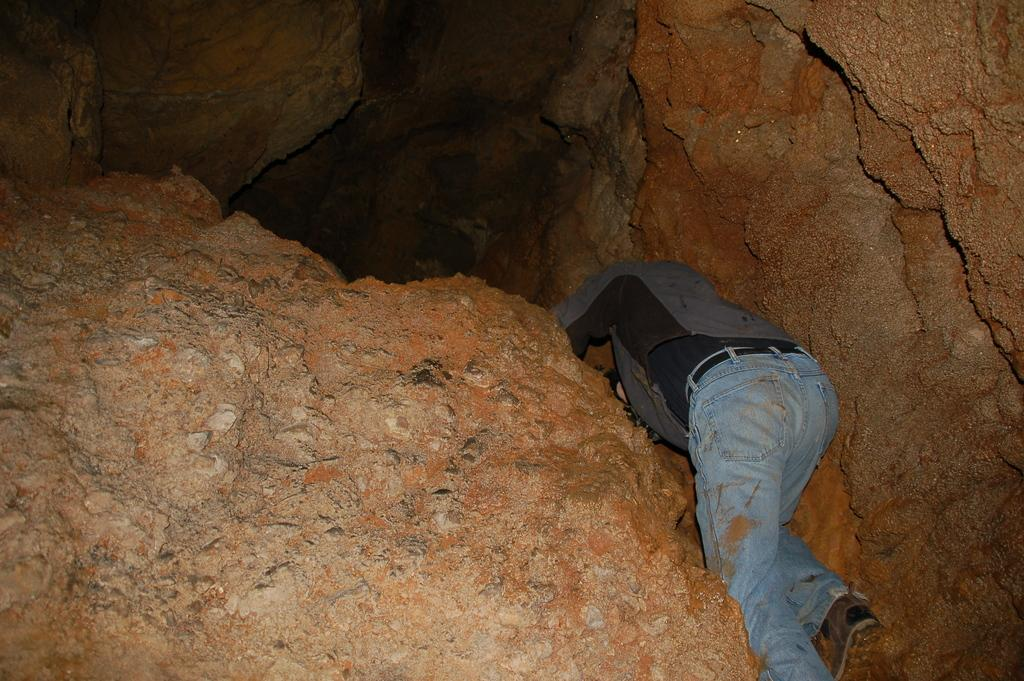What is present in the image? There is a man and rocks in the image. Can you describe the man in the image? The provided facts do not give any specific details about the man, so we cannot describe him further. What type of cushion is being used by the babies in the image? There are no babies or cushions present in the image. How many balloons are visible in the image? There are no balloons present in the image. 